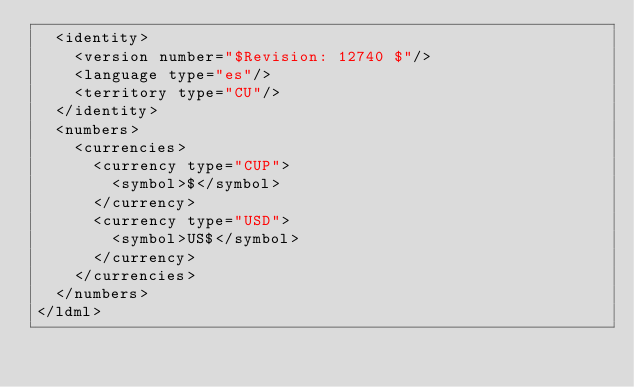Convert code to text. <code><loc_0><loc_0><loc_500><loc_500><_XML_>	<identity>
		<version number="$Revision: 12740 $"/>
		<language type="es"/>
		<territory type="CU"/>
	</identity>
	<numbers>
		<currencies>
			<currency type="CUP">
				<symbol>$</symbol>
			</currency>
			<currency type="USD">
				<symbol>US$</symbol>
			</currency>
		</currencies>
	</numbers>
</ldml>
</code> 